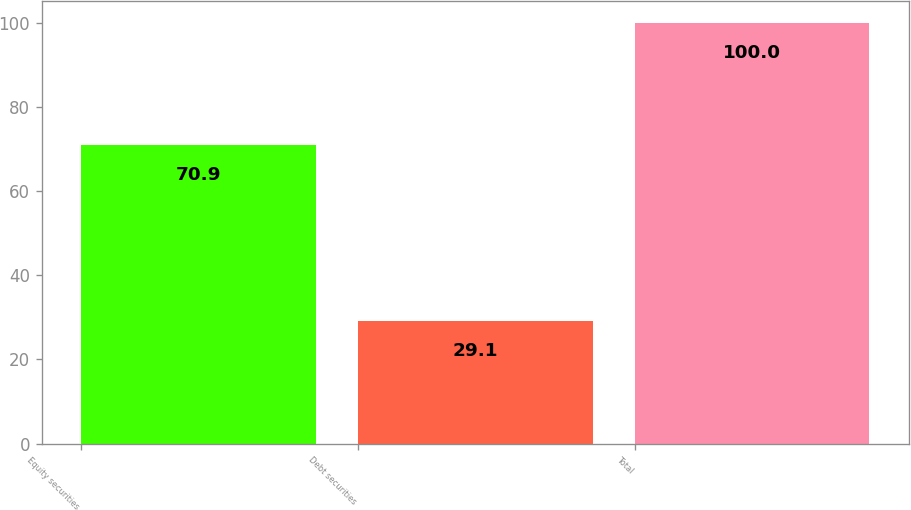Convert chart. <chart><loc_0><loc_0><loc_500><loc_500><bar_chart><fcel>Equity securities<fcel>Debt securities<fcel>Total<nl><fcel>70.9<fcel>29.1<fcel>100<nl></chart> 